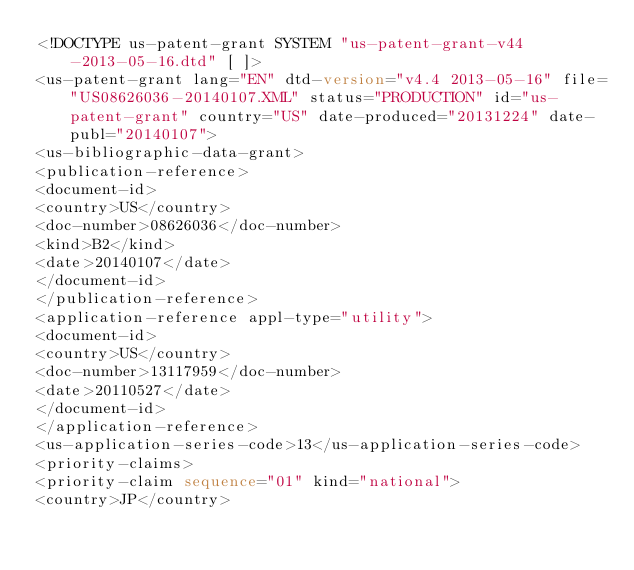<code> <loc_0><loc_0><loc_500><loc_500><_XML_><!DOCTYPE us-patent-grant SYSTEM "us-patent-grant-v44-2013-05-16.dtd" [ ]>
<us-patent-grant lang="EN" dtd-version="v4.4 2013-05-16" file="US08626036-20140107.XML" status="PRODUCTION" id="us-patent-grant" country="US" date-produced="20131224" date-publ="20140107">
<us-bibliographic-data-grant>
<publication-reference>
<document-id>
<country>US</country>
<doc-number>08626036</doc-number>
<kind>B2</kind>
<date>20140107</date>
</document-id>
</publication-reference>
<application-reference appl-type="utility">
<document-id>
<country>US</country>
<doc-number>13117959</doc-number>
<date>20110527</date>
</document-id>
</application-reference>
<us-application-series-code>13</us-application-series-code>
<priority-claims>
<priority-claim sequence="01" kind="national">
<country>JP</country></code> 